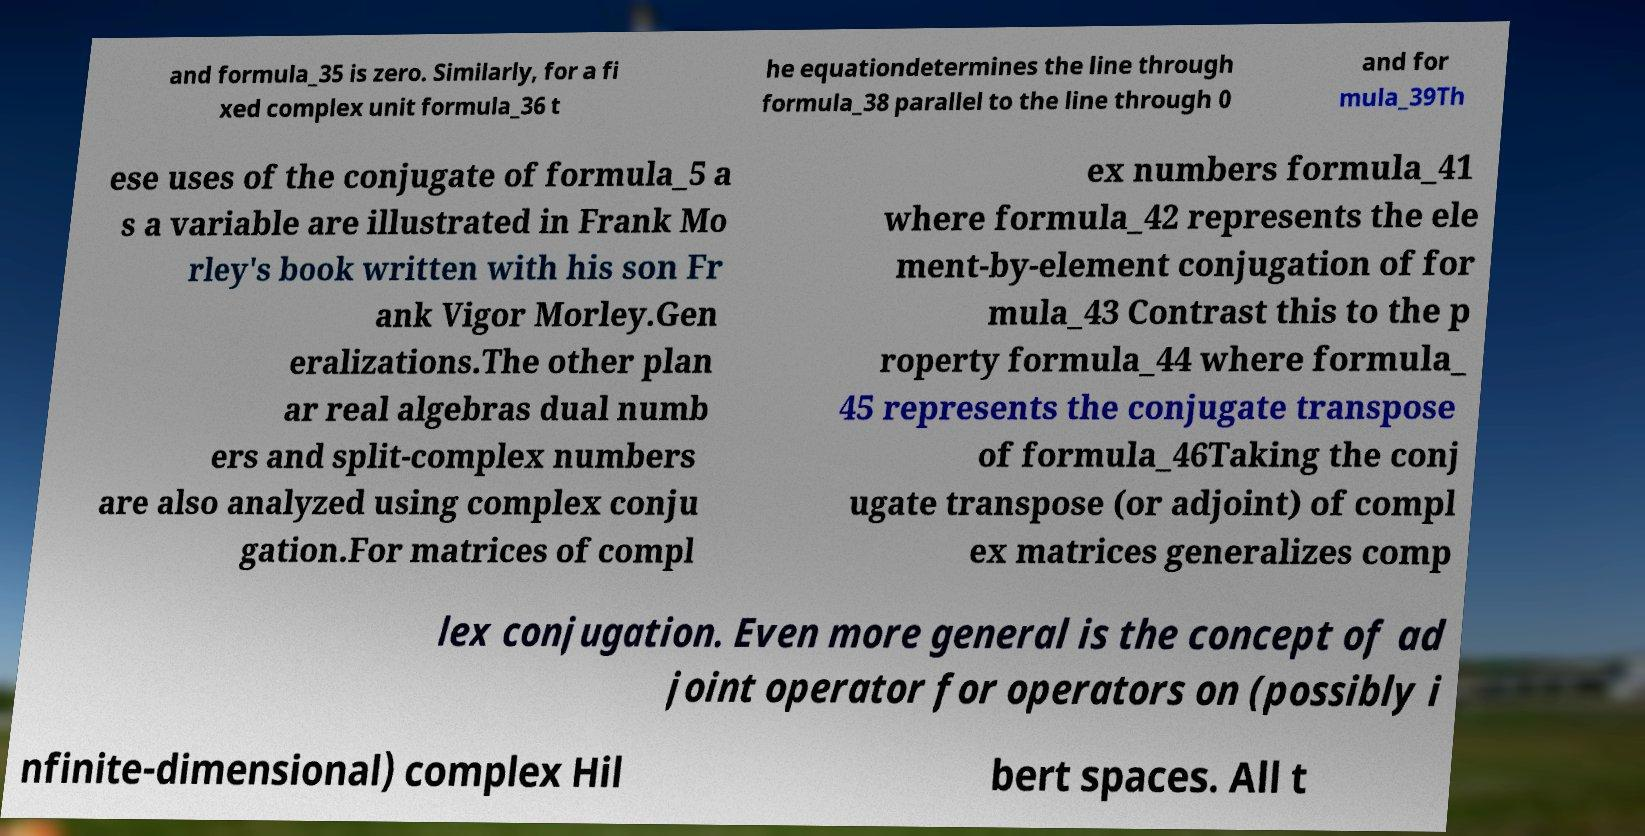I need the written content from this picture converted into text. Can you do that? and formula_35 is zero. Similarly, for a fi xed complex unit formula_36 t he equationdetermines the line through formula_38 parallel to the line through 0 and for mula_39Th ese uses of the conjugate of formula_5 a s a variable are illustrated in Frank Mo rley's book written with his son Fr ank Vigor Morley.Gen eralizations.The other plan ar real algebras dual numb ers and split-complex numbers are also analyzed using complex conju gation.For matrices of compl ex numbers formula_41 where formula_42 represents the ele ment-by-element conjugation of for mula_43 Contrast this to the p roperty formula_44 where formula_ 45 represents the conjugate transpose of formula_46Taking the conj ugate transpose (or adjoint) of compl ex matrices generalizes comp lex conjugation. Even more general is the concept of ad joint operator for operators on (possibly i nfinite-dimensional) complex Hil bert spaces. All t 